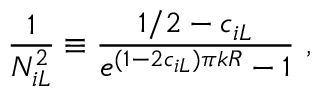<formula> <loc_0><loc_0><loc_500><loc_500>\frac { 1 } { N _ { i L } ^ { 2 } } \equiv \frac { 1 / 2 - c _ { i L } } { e ^ { ( 1 - 2 c _ { i L } ) \pi k R } - 1 } ,</formula> 